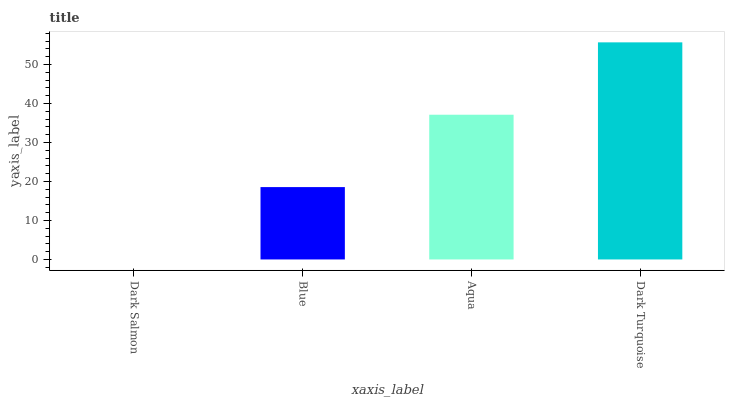Is Dark Salmon the minimum?
Answer yes or no. Yes. Is Dark Turquoise the maximum?
Answer yes or no. Yes. Is Blue the minimum?
Answer yes or no. No. Is Blue the maximum?
Answer yes or no. No. Is Blue greater than Dark Salmon?
Answer yes or no. Yes. Is Dark Salmon less than Blue?
Answer yes or no. Yes. Is Dark Salmon greater than Blue?
Answer yes or no. No. Is Blue less than Dark Salmon?
Answer yes or no. No. Is Aqua the high median?
Answer yes or no. Yes. Is Blue the low median?
Answer yes or no. Yes. Is Dark Turquoise the high median?
Answer yes or no. No. Is Dark Salmon the low median?
Answer yes or no. No. 